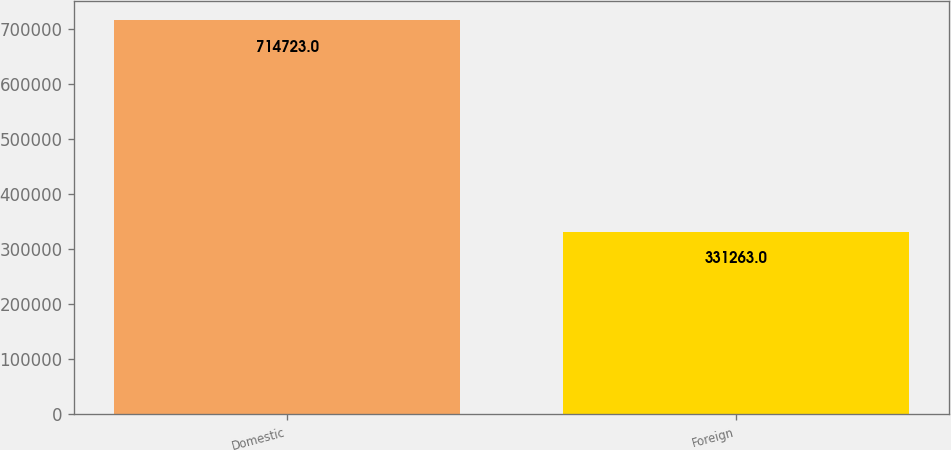<chart> <loc_0><loc_0><loc_500><loc_500><bar_chart><fcel>Domestic<fcel>Foreign<nl><fcel>714723<fcel>331263<nl></chart> 